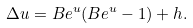<formula> <loc_0><loc_0><loc_500><loc_500>\Delta u = B e ^ { u } ( B e ^ { u } - 1 ) + h .</formula> 